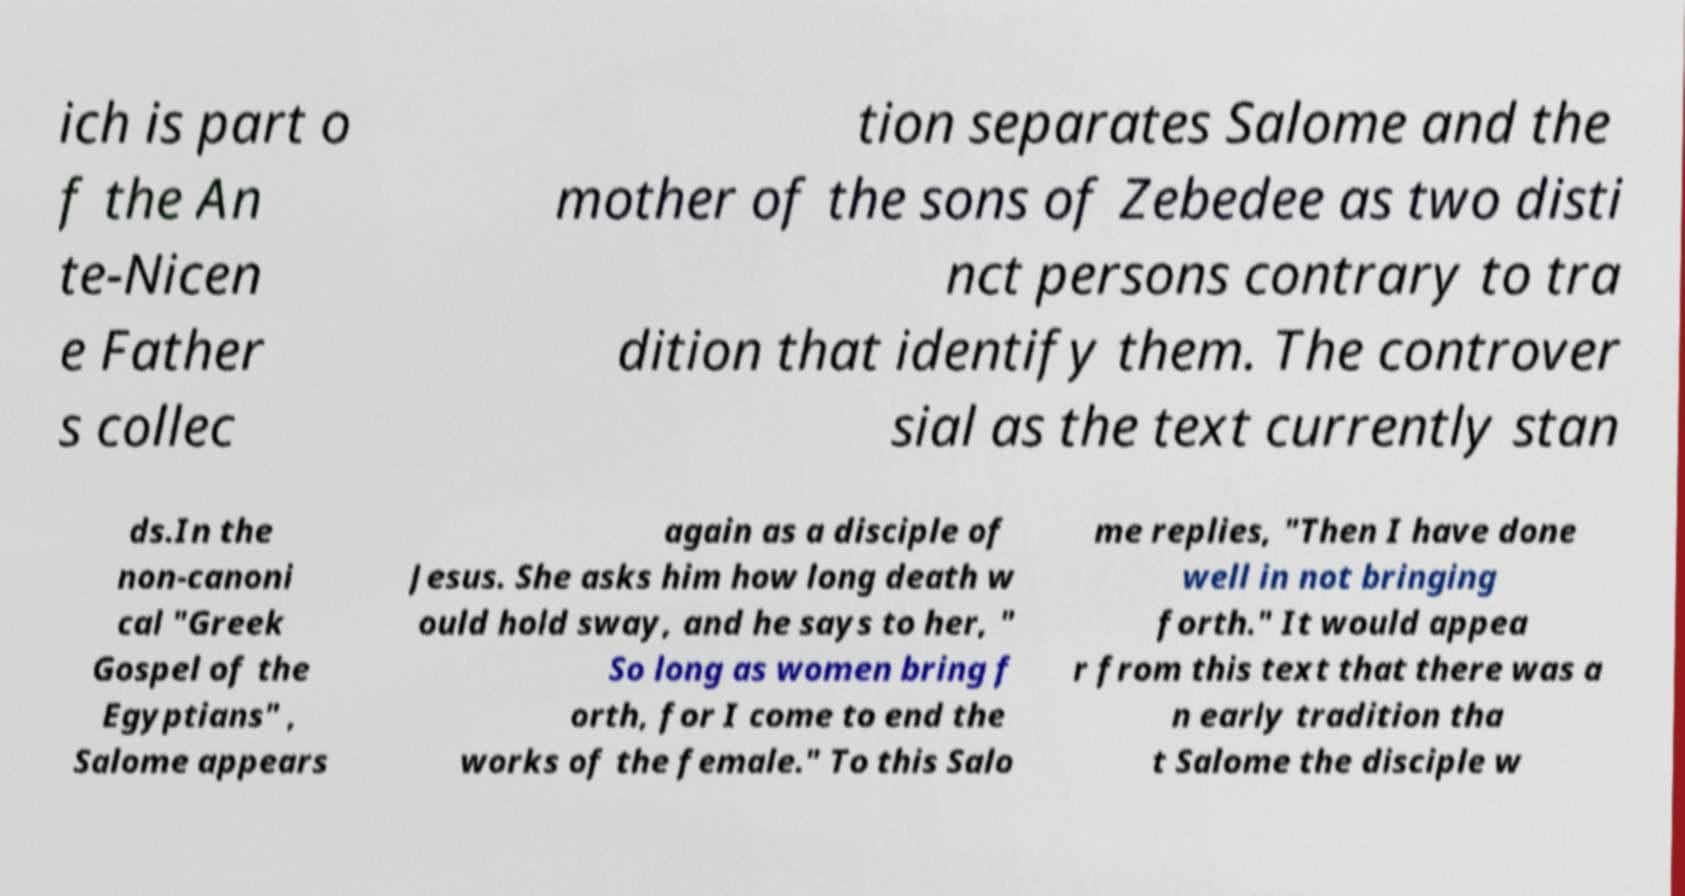Please identify and transcribe the text found in this image. ich is part o f the An te-Nicen e Father s collec tion separates Salome and the mother of the sons of Zebedee as two disti nct persons contrary to tra dition that identify them. The controver sial as the text currently stan ds.In the non-canoni cal "Greek Gospel of the Egyptians" , Salome appears again as a disciple of Jesus. She asks him how long death w ould hold sway, and he says to her, " So long as women bring f orth, for I come to end the works of the female." To this Salo me replies, "Then I have done well in not bringing forth." It would appea r from this text that there was a n early tradition tha t Salome the disciple w 